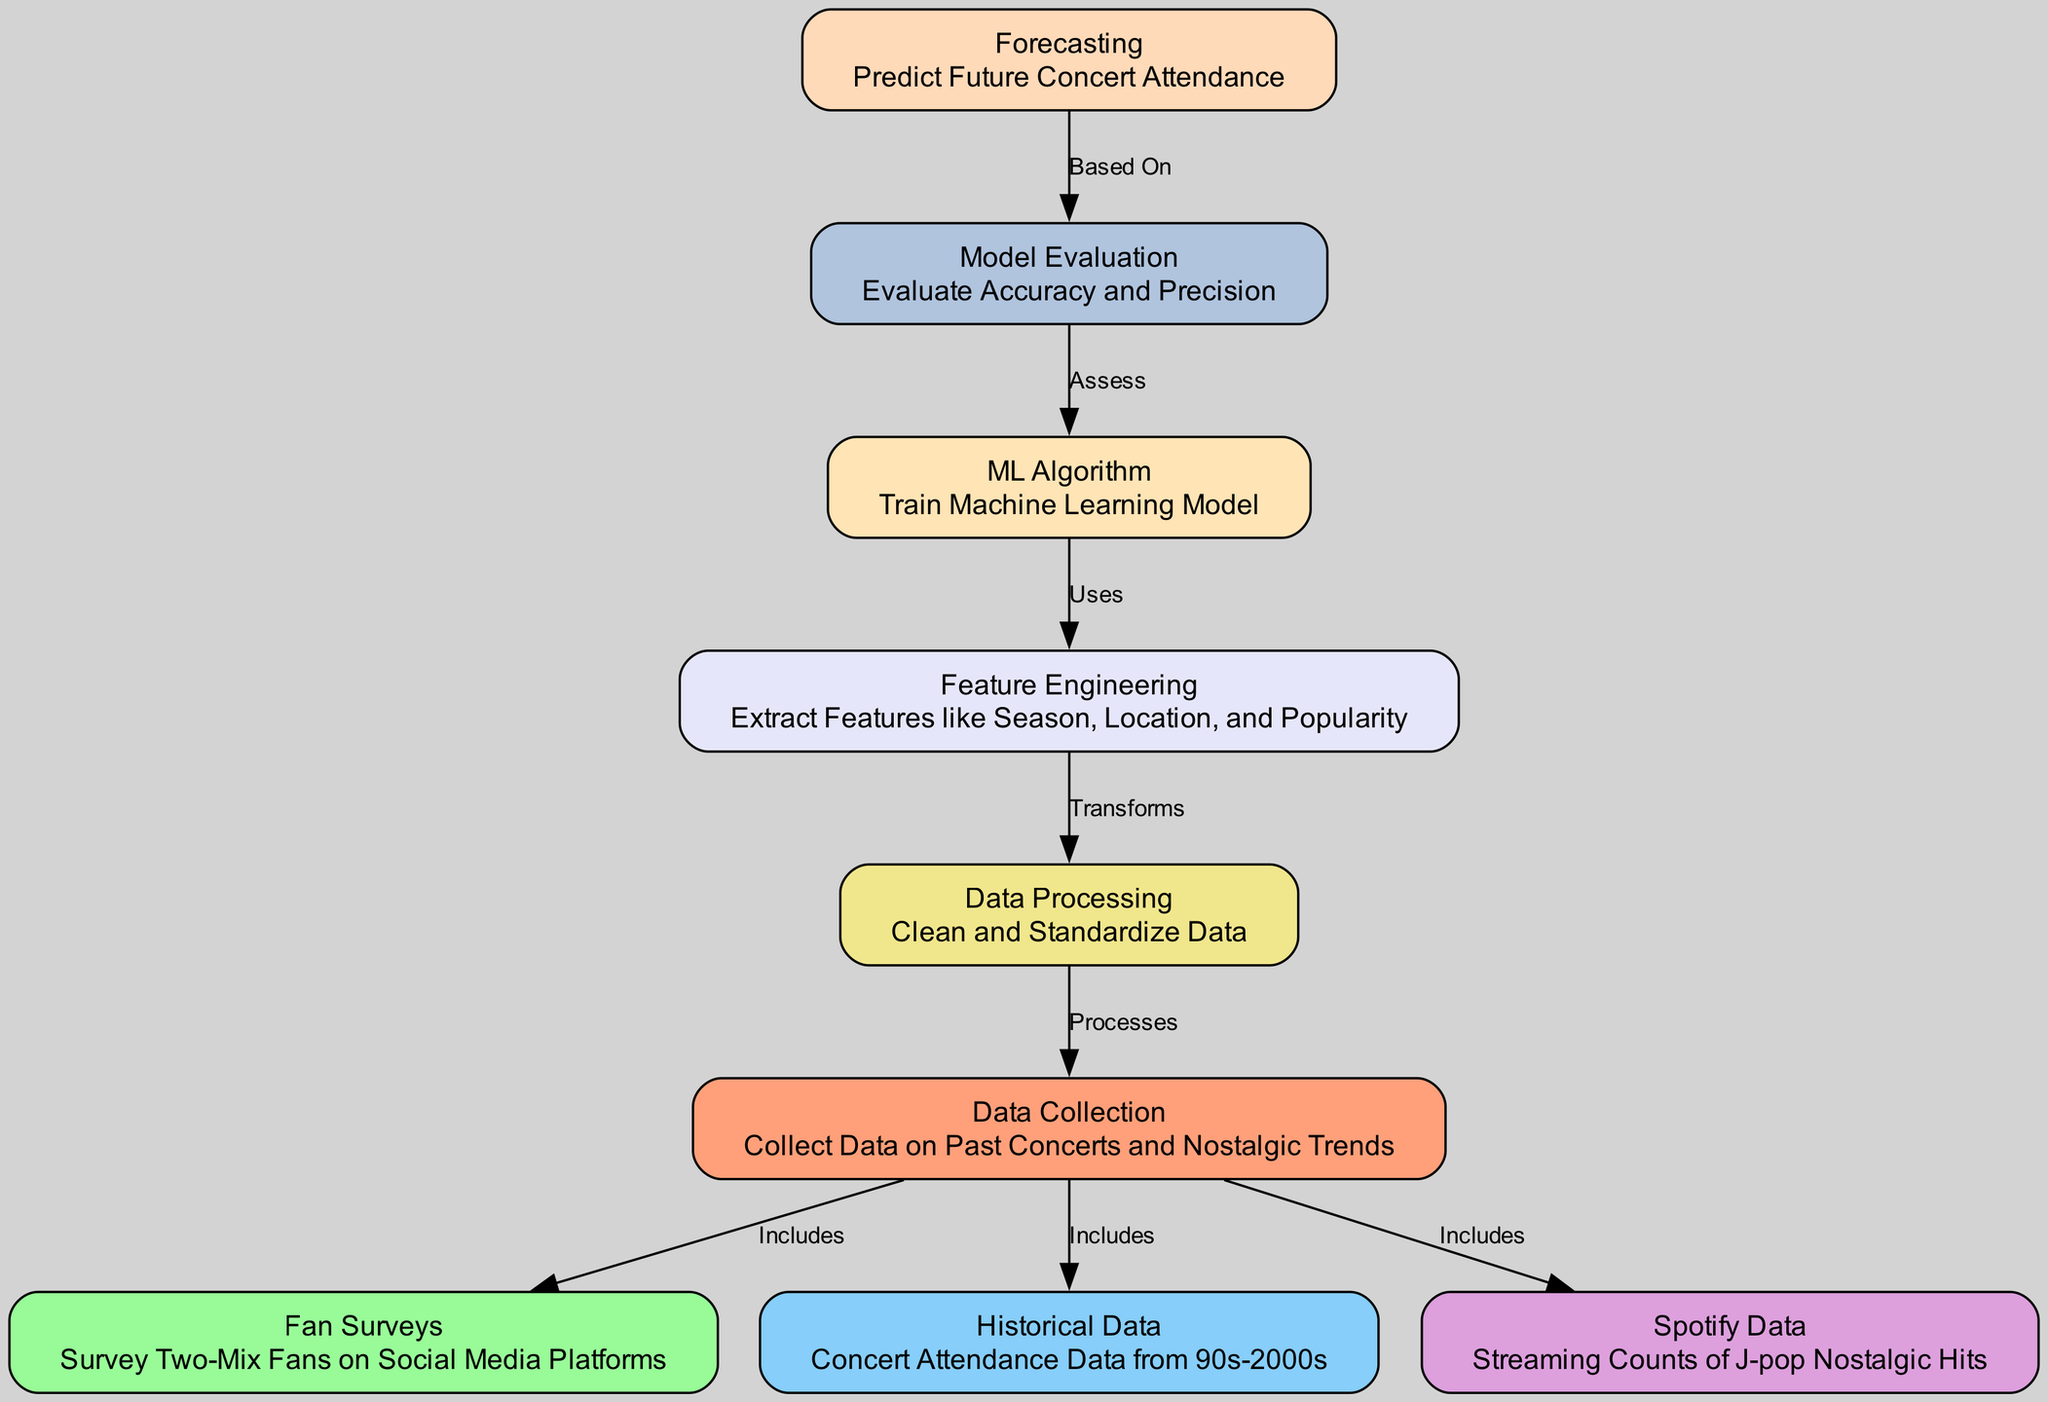What is the total number of nodes in the diagram? The diagram includes a list of nodes which represents distinct processes or actions in the machine learning workflow. By counting the nodes listed, we find there are 9 total nodes present.
Answer: 9 What does the edge between Data Collection and Fan Surveys signify? The edge labeled "Includes" indicates that the Fan Surveys are part of the data that is collected in the Data Collection step. This means that information gathered from fan surveys contributes to the data analyzed.
Answer: Includes Which node processes data from Data Collection? The Data Processing node directly receives input from the Data Collection node, indicating it is responsible for processing the collected data. This is shown by the "Processes" label on the edge connecting them.
Answer: Data Processing What feature is extracted in the Feature Engineering node? The Feature Engineering node includes the extraction of various features, one of which listed is "Popularity." This detail is part of the node’s explanation about what features are considered for enhancing the model’s performance.
Answer: Popularity How does Model Evaluation relate to ML Algorithm? The Model Evaluation node has an edge that states it "Assesses" the ML Algorithm. This means that the evaluation process is based on the results or outputs of the machine learning model, implying a dependency between both nodes.
Answer: Assesses Which data group is categorized as historical? The Historical Data node specifically refers to "Concert Attendance Data from 90s-2000s," indicating that this group contains older concert-related attendance records that are utilized for analysis.
Answer: Historical Data What is the final output of the machine learning process represented in the diagram? The final output is represented by the Forecasting node, which is about predicting future concert attendance based on the preceding steps and model evaluation processes that have occurred.
Answer: Forecasting Which node serves as the foundation for Feature Engineering? The Feature Engineering node transforms data processed by the Data Processing node, as indicated by the "Transforms" label on the edge connecting these two nodes, establishing a direct dependency.
Answer: Data Processing 